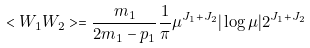<formula> <loc_0><loc_0><loc_500><loc_500>< W _ { 1 } W _ { 2 } > = \frac { m _ { 1 } } { 2 m _ { 1 } - p _ { 1 } } \frac { 1 } { \pi } \mu ^ { J _ { 1 } + J _ { 2 } } | \log \mu | 2 ^ { J _ { 1 } + J _ { 2 } }</formula> 